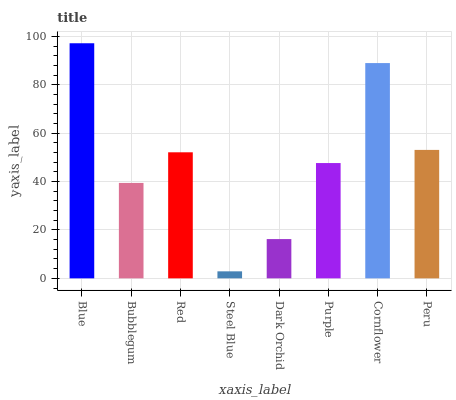Is Steel Blue the minimum?
Answer yes or no. Yes. Is Blue the maximum?
Answer yes or no. Yes. Is Bubblegum the minimum?
Answer yes or no. No. Is Bubblegum the maximum?
Answer yes or no. No. Is Blue greater than Bubblegum?
Answer yes or no. Yes. Is Bubblegum less than Blue?
Answer yes or no. Yes. Is Bubblegum greater than Blue?
Answer yes or no. No. Is Blue less than Bubblegum?
Answer yes or no. No. Is Red the high median?
Answer yes or no. Yes. Is Purple the low median?
Answer yes or no. Yes. Is Dark Orchid the high median?
Answer yes or no. No. Is Dark Orchid the low median?
Answer yes or no. No. 